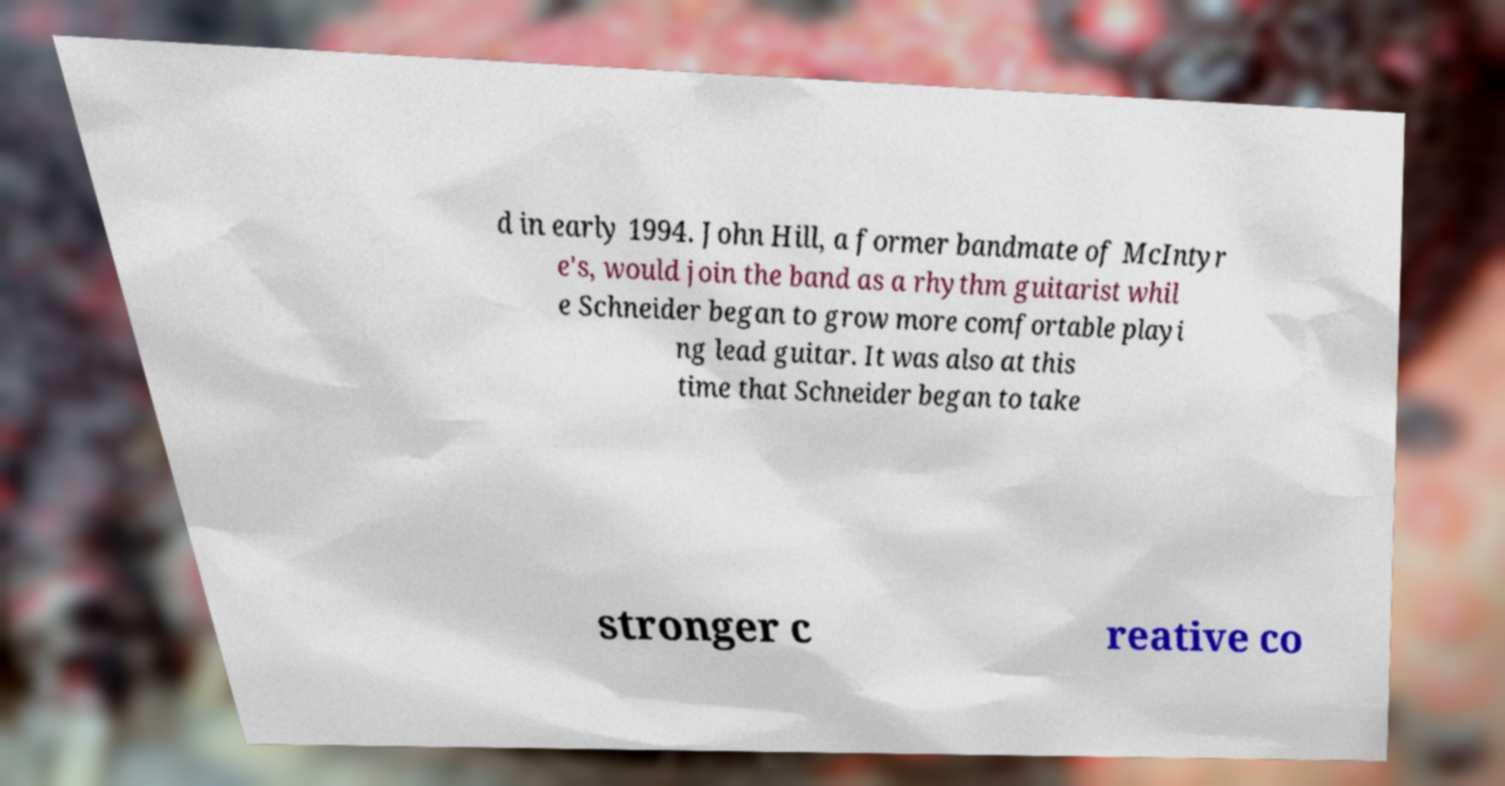Please identify and transcribe the text found in this image. d in early 1994. John Hill, a former bandmate of McIntyr e's, would join the band as a rhythm guitarist whil e Schneider began to grow more comfortable playi ng lead guitar. It was also at this time that Schneider began to take stronger c reative co 